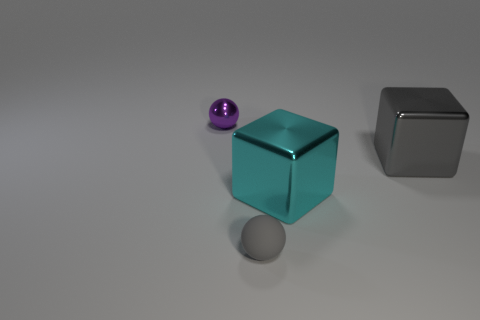There is a ball behind the small gray rubber object on the right side of the purple metallic sphere; what is it made of?
Your answer should be compact. Metal. Is the size of the gray shiny block the same as the thing that is to the left of the tiny gray thing?
Your answer should be compact. No. Are there more tiny spheres that are behind the gray block than small yellow matte cylinders?
Your answer should be very brief. Yes. The cyan block that is the same material as the gray cube is what size?
Offer a terse response. Large. Are there any other small spheres of the same color as the rubber sphere?
Provide a succinct answer. No. What number of things are balls or tiny objects in front of the small metallic object?
Your answer should be very brief. 2. Is the number of purple metal spheres greater than the number of big metal blocks?
Offer a terse response. No. Is there a yellow ball that has the same material as the gray ball?
Keep it short and to the point. No. There is a thing that is both behind the small gray thing and to the left of the cyan metallic cube; what shape is it?
Ensure brevity in your answer.  Sphere. The cyan object is what size?
Keep it short and to the point. Large. 